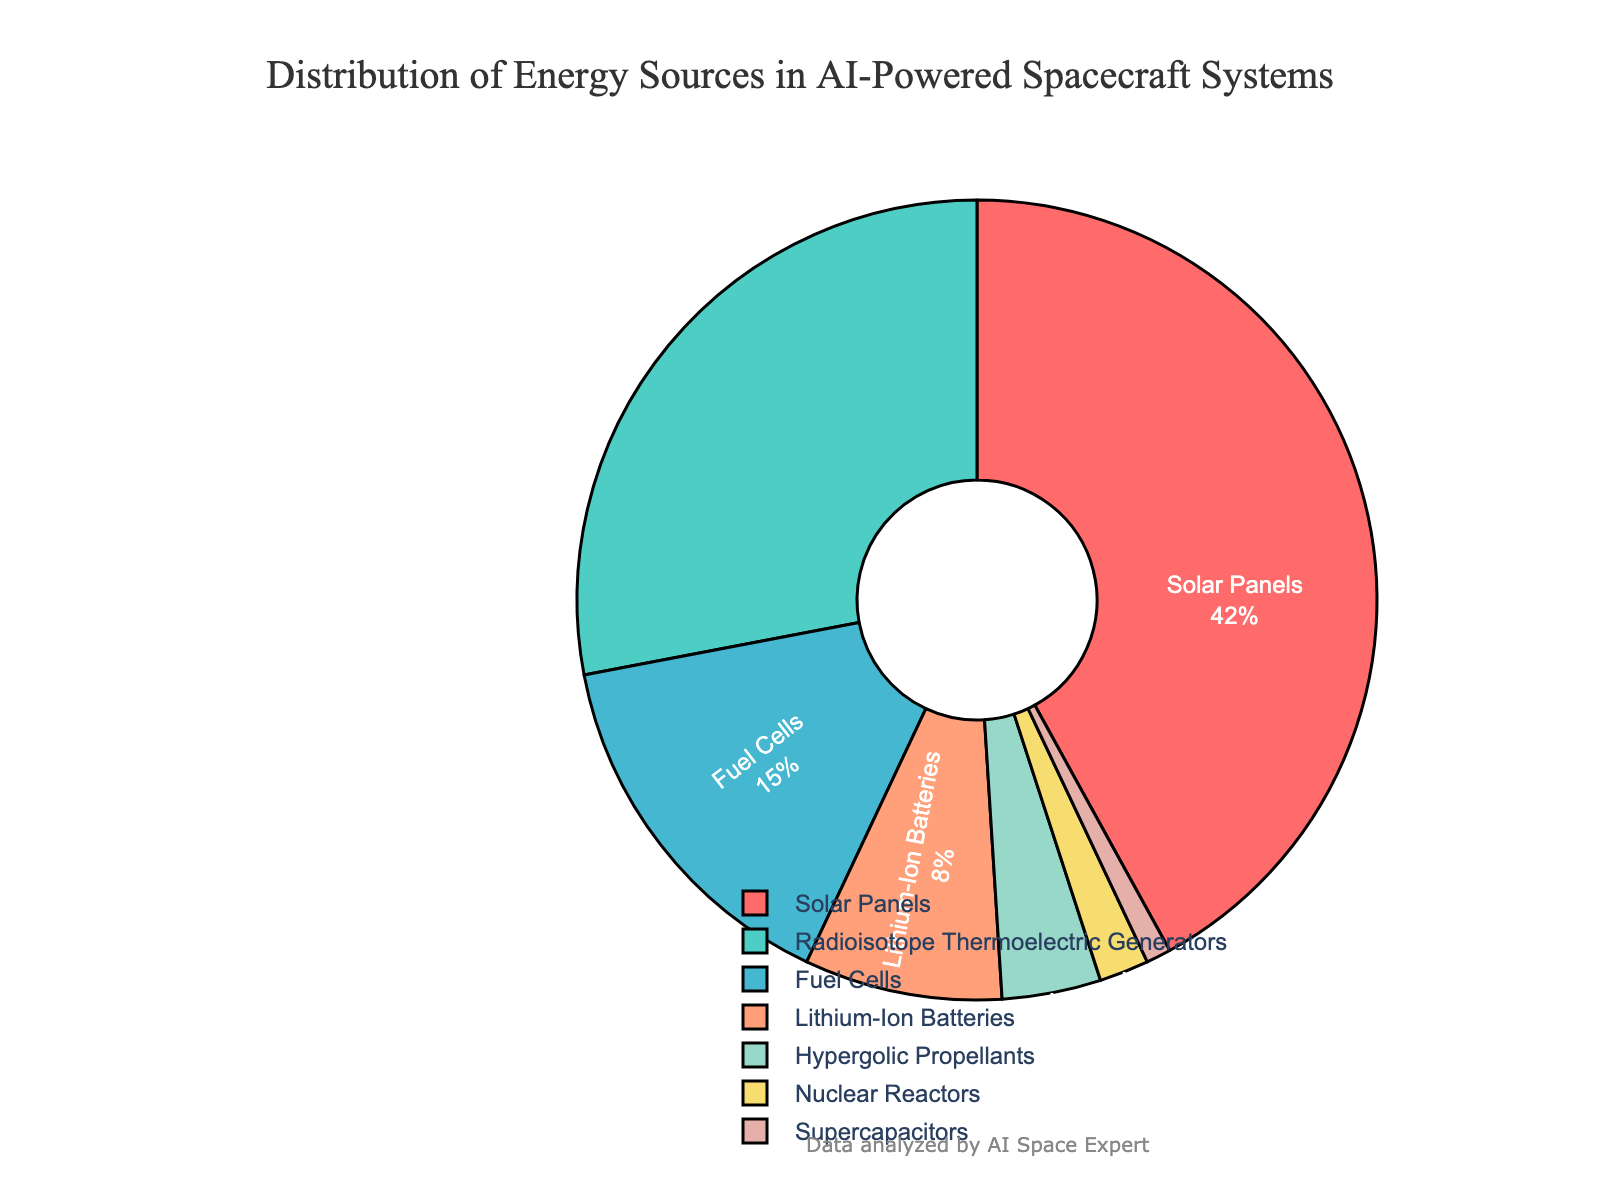Which energy source contributes the highest percentage? From the pie chart, the largest section corresponds to Solar Panels, which indicates it contributes the highest percentage.
Answer: Solar Panels What is the combined percentage of fuel cells and lithium-ion batteries? According to the pie chart, fuel cells contribute 15% and lithium-ion batteries contribute 8%. Summing these up: 15 + 8 = 23%.
Answer: 23% Are solar panels used more than radioisotope thermoelectric generators? The chart shows that solar panels have a larger section (42%) compared to radioisotope thermoelectric generators (28%), indicating higher usage.
Answer: Yes Which energy source accounts for the smallest percentage? Observing the chart, the smallest section corresponds to supercapacitors, which accounts for 1%.
Answer: Supercapacitors How much greater is the contribution of solar panels compared to hypergolic propellants? The chart indicates that solar panels contribute 42% and hypergolic propellants contribute 4%. The difference is 42 - 4 = 38%.
Answer: 38% What is the total percentage of all energy sources that contribute less than 10% each? From the pie chart, lithium-ion batteries (8%), hypergolic propellants (4%), nuclear reactors (2%), and supercapacitors (1%) each contribute less than 10%. Adding them: 8 + 4 + 2 + 1 = 15%.
Answer: 15% How does the contribution of nuclear reactors compare to that of lithium-ion batteries? The pie chart shows that nuclear reactors contribute 2% whereas lithium-ion batteries contribute 8%. Therefore, nuclear reactors contribute less than lithium-ion batteries.
Answer: Less What visually distinctive color represents the largest portion of energy sources? The segment for solar panels, marked in red, is the most visually distinctive and occupies the largest portion of the chart.
Answer: Red Is the combined contribution of hypergolic propellants, nuclear reactors, and supercapacitors less than that of fuel cells? According to the pie chart: hypergolic propellants (4%) + nuclear reactors (2%) + supercapacitors (1%) = 4 + 2 + 1 = 7%, which is less than fuel cells' 15%.
Answer: Yes 